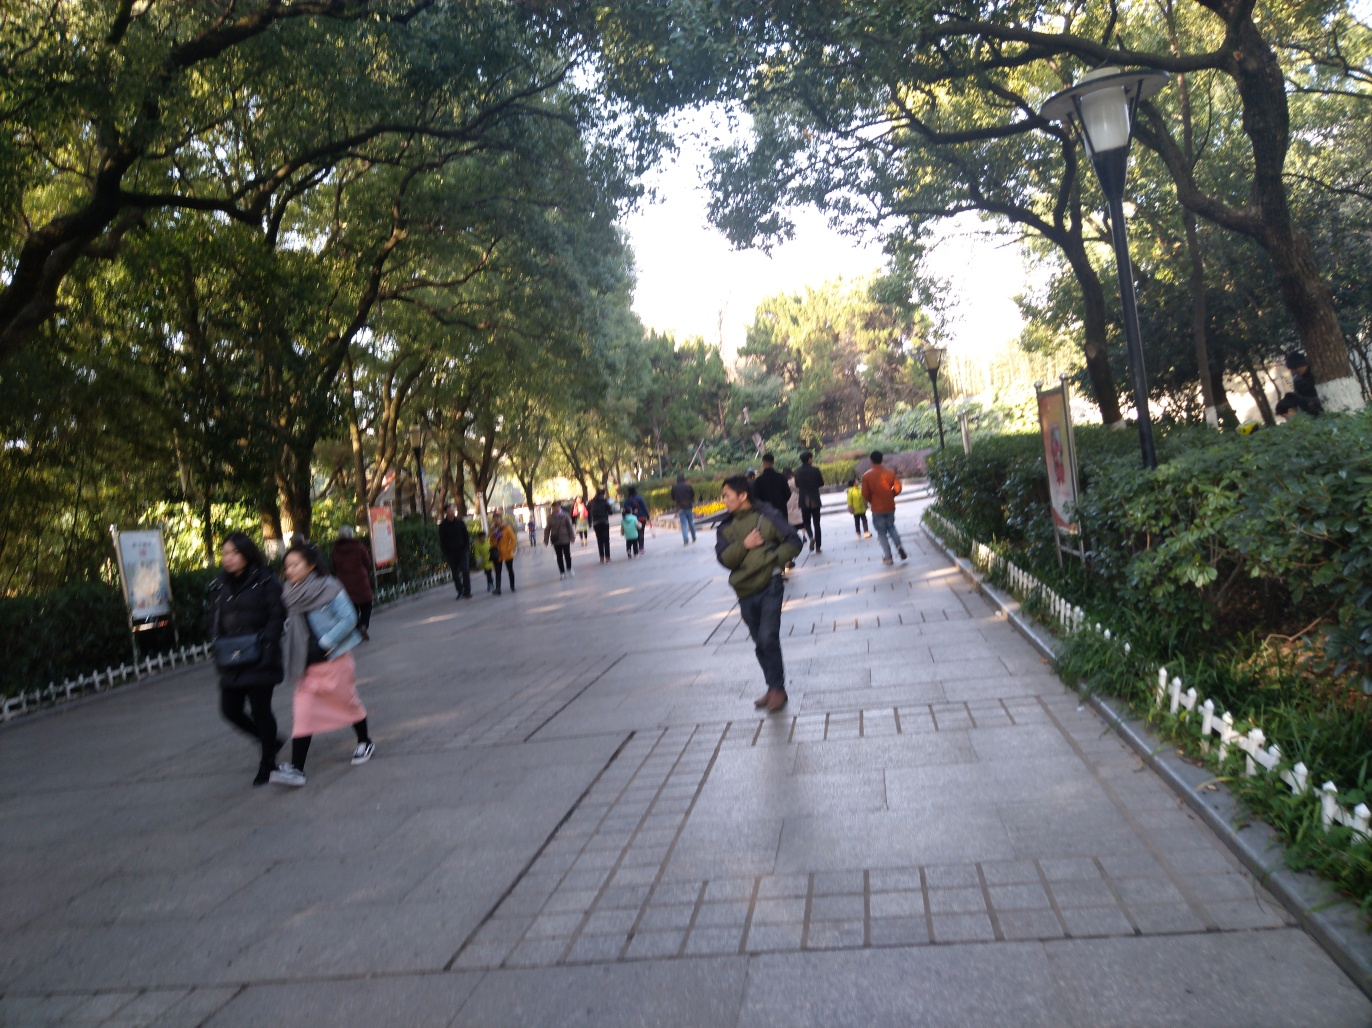What mood does this image evoke and why? The image evokes a mood of casual everyday activity, potentially conveying the calmness of a routine walk in a park or urban pathway. The presence of trees and the soft shadows they cast contribute to a tranquil and restful atmosphere. Although the image is a bit blurred, it still manages to suggest a snapshot of life in motion, which could be seen as an authentic representation of a moment in time. 